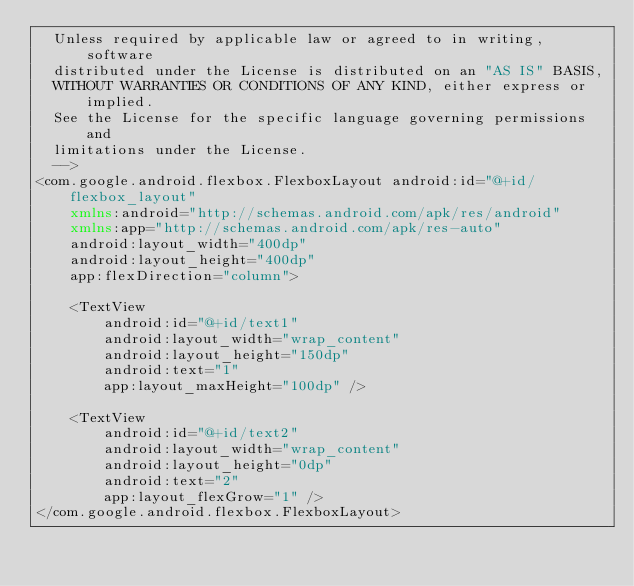<code> <loc_0><loc_0><loc_500><loc_500><_XML_>  Unless required by applicable law or agreed to in writing, software
  distributed under the License is distributed on an "AS IS" BASIS,
  WITHOUT WARRANTIES OR CONDITIONS OF ANY KIND, either express or implied.
  See the License for the specific language governing permissions and
  limitations under the License.
  -->
<com.google.android.flexbox.FlexboxLayout android:id="@+id/flexbox_layout"
    xmlns:android="http://schemas.android.com/apk/res/android"
    xmlns:app="http://schemas.android.com/apk/res-auto"
    android:layout_width="400dp"
    android:layout_height="400dp"
    app:flexDirection="column">

    <TextView
        android:id="@+id/text1"
        android:layout_width="wrap_content"
        android:layout_height="150dp"
        android:text="1"
        app:layout_maxHeight="100dp" />

    <TextView
        android:id="@+id/text2"
        android:layout_width="wrap_content"
        android:layout_height="0dp"
        android:text="2"
        app:layout_flexGrow="1" />
</com.google.android.flexbox.FlexboxLayout></code> 